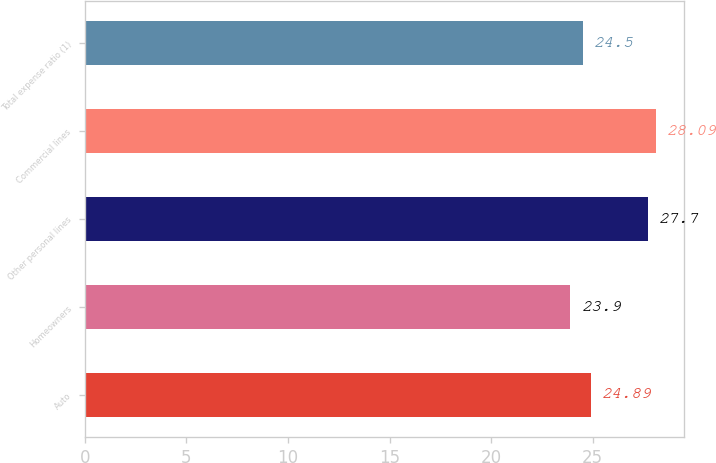<chart> <loc_0><loc_0><loc_500><loc_500><bar_chart><fcel>Auto<fcel>Homeowners<fcel>Other personal lines<fcel>Commercial lines<fcel>Total expense ratio (1)<nl><fcel>24.89<fcel>23.9<fcel>27.7<fcel>28.09<fcel>24.5<nl></chart> 